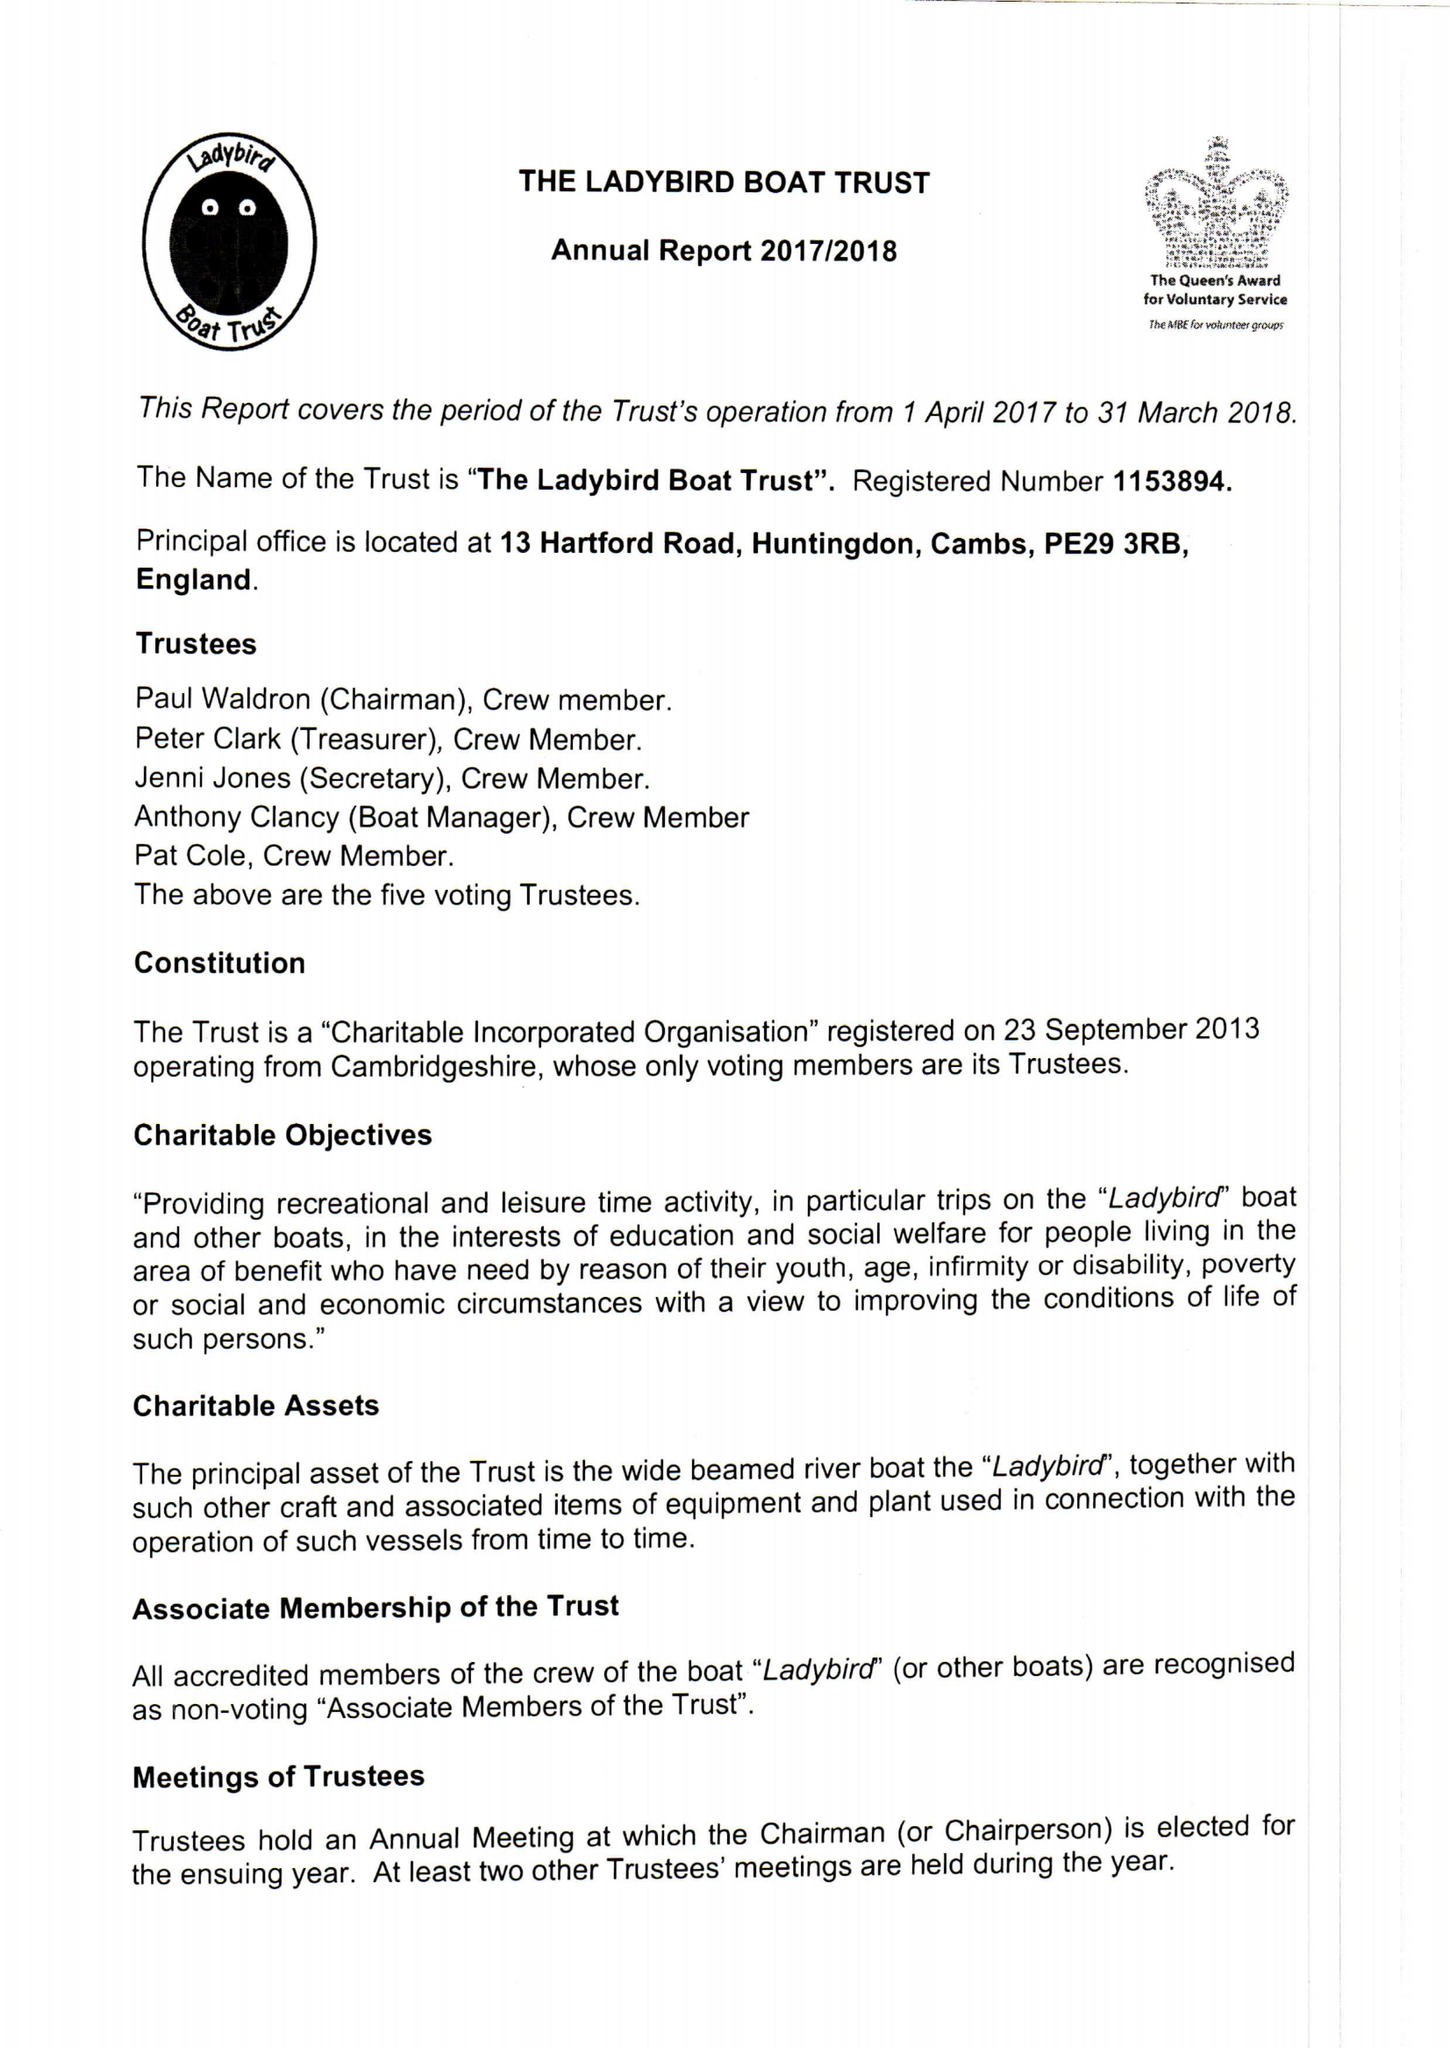What is the value for the address__postcode?
Answer the question using a single word or phrase. PE29 3RB 